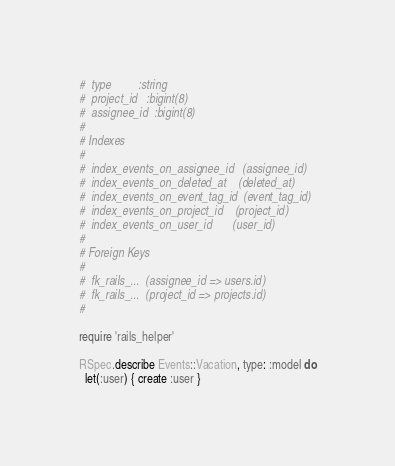Convert code to text. <code><loc_0><loc_0><loc_500><loc_500><_Ruby_>#  type         :string
#  project_id   :bigint(8)
#  assignee_id  :bigint(8)
#
# Indexes
#
#  index_events_on_assignee_id   (assignee_id)
#  index_events_on_deleted_at    (deleted_at)
#  index_events_on_event_tag_id  (event_tag_id)
#  index_events_on_project_id    (project_id)
#  index_events_on_user_id       (user_id)
#
# Foreign Keys
#
#  fk_rails_...  (assignee_id => users.id)
#  fk_rails_...  (project_id => projects.id)
#

require 'rails_helper'

RSpec.describe Events::Vacation, type: :model do
  let(:user) { create :user }</code> 